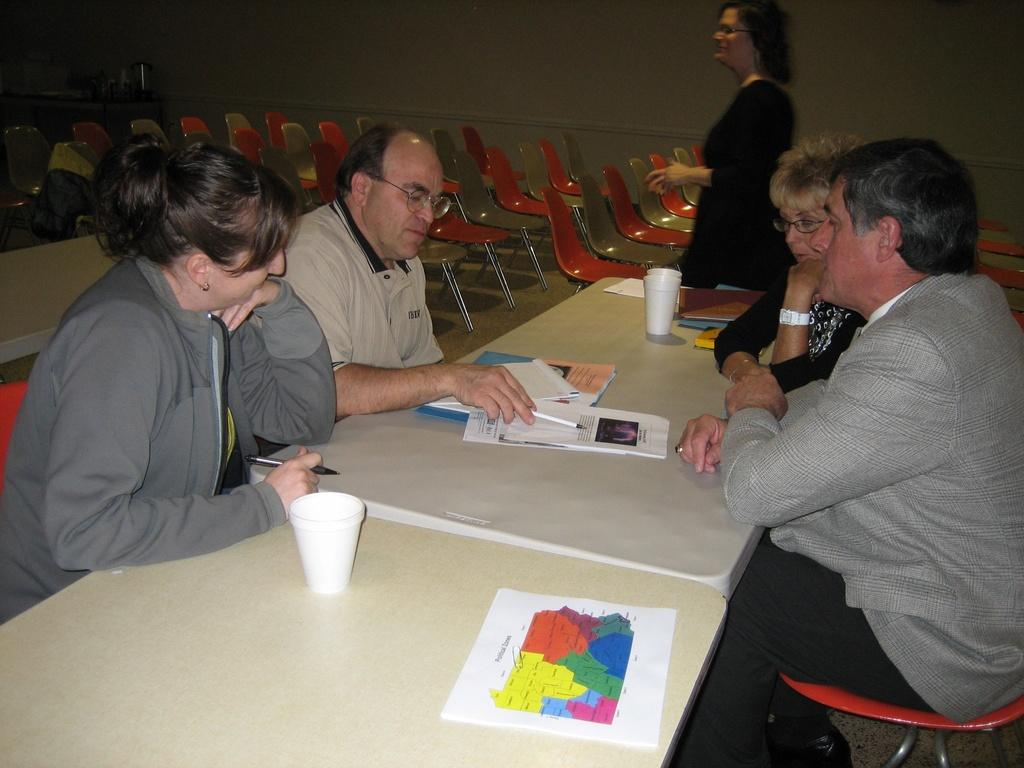What type of structure can be seen in the image? There is a wall in the image. What type of furniture is present in the image? There are chairs and a table in the image. Are there any people in the image? Yes, there are people in the image. What items can be seen on the table in the image? There is a paper, a glass, a book, and a pen on the table in the image. What historical event is being discussed by the people in the image? There is no indication of a historical event being discussed in the image. What type of grain is present on the table in the image? There is no grain present on the table in the image. 